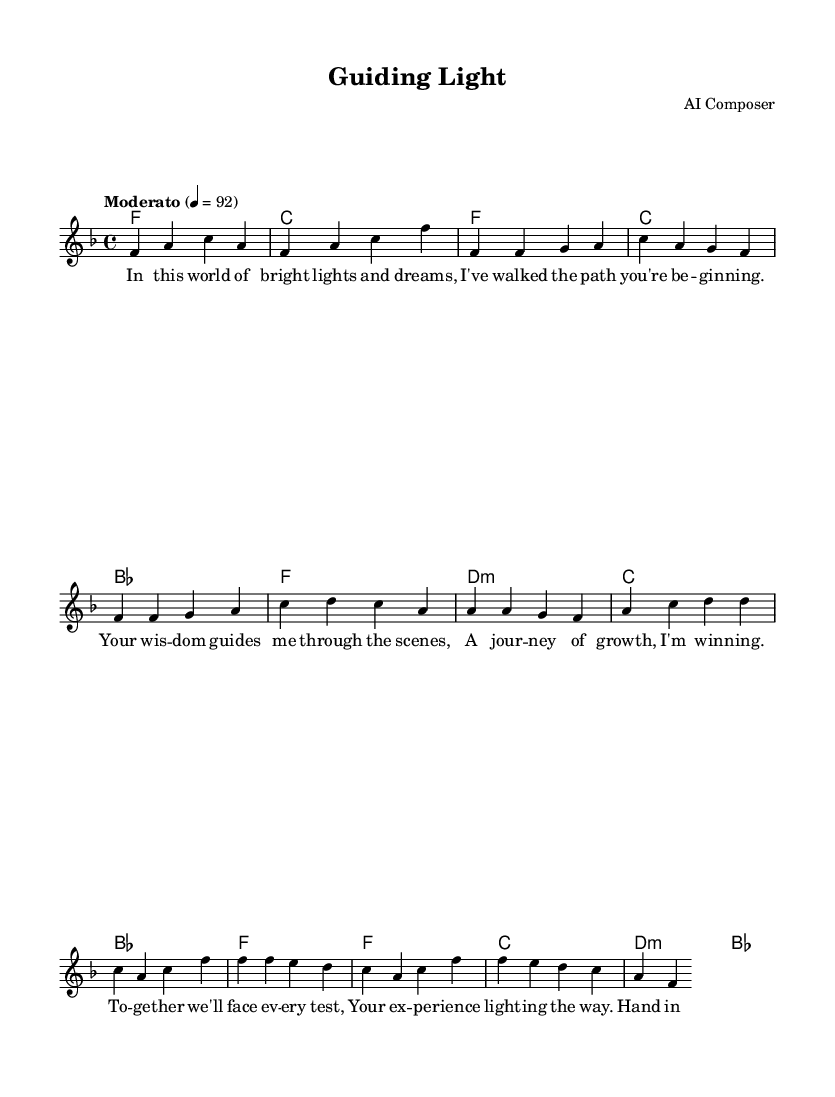What is the key signature of this music? The key signature is F major, which has one flat (B flat).
Answer: F major What is the time signature of this piece? The time signature is 4/4, which means there are four beats in each measure.
Answer: 4/4 What is the tempo marking indicated in the music? The tempo marking is "Moderato," which indicates a moderate speed.
Answer: Moderato How many measures are there in the chorus section? In the chorus, there are 4 measures, as indicated by the four lines of music for that section.
Answer: 4 What is the primary theme explored in the lyrics of this duet? The primary theme revolves around a mentor guiding a mentee, highlighting growth and collaboration.
Answer: Mentor-mentee relationship Which musical element indicates the emotional tone of this piece? The use of harmonies and the lyrical content aimed at nurturing and support signifies an emotional tone of warmth and encouragement.
Answer: Harmonies How does the pre-chorus relate to the overall message of the song? The pre-chorus emphasizes unity and facing challenges together, reinforcing the bond between mentor and mentee, which aligns with the song's theme of growth.
Answer: Unity 